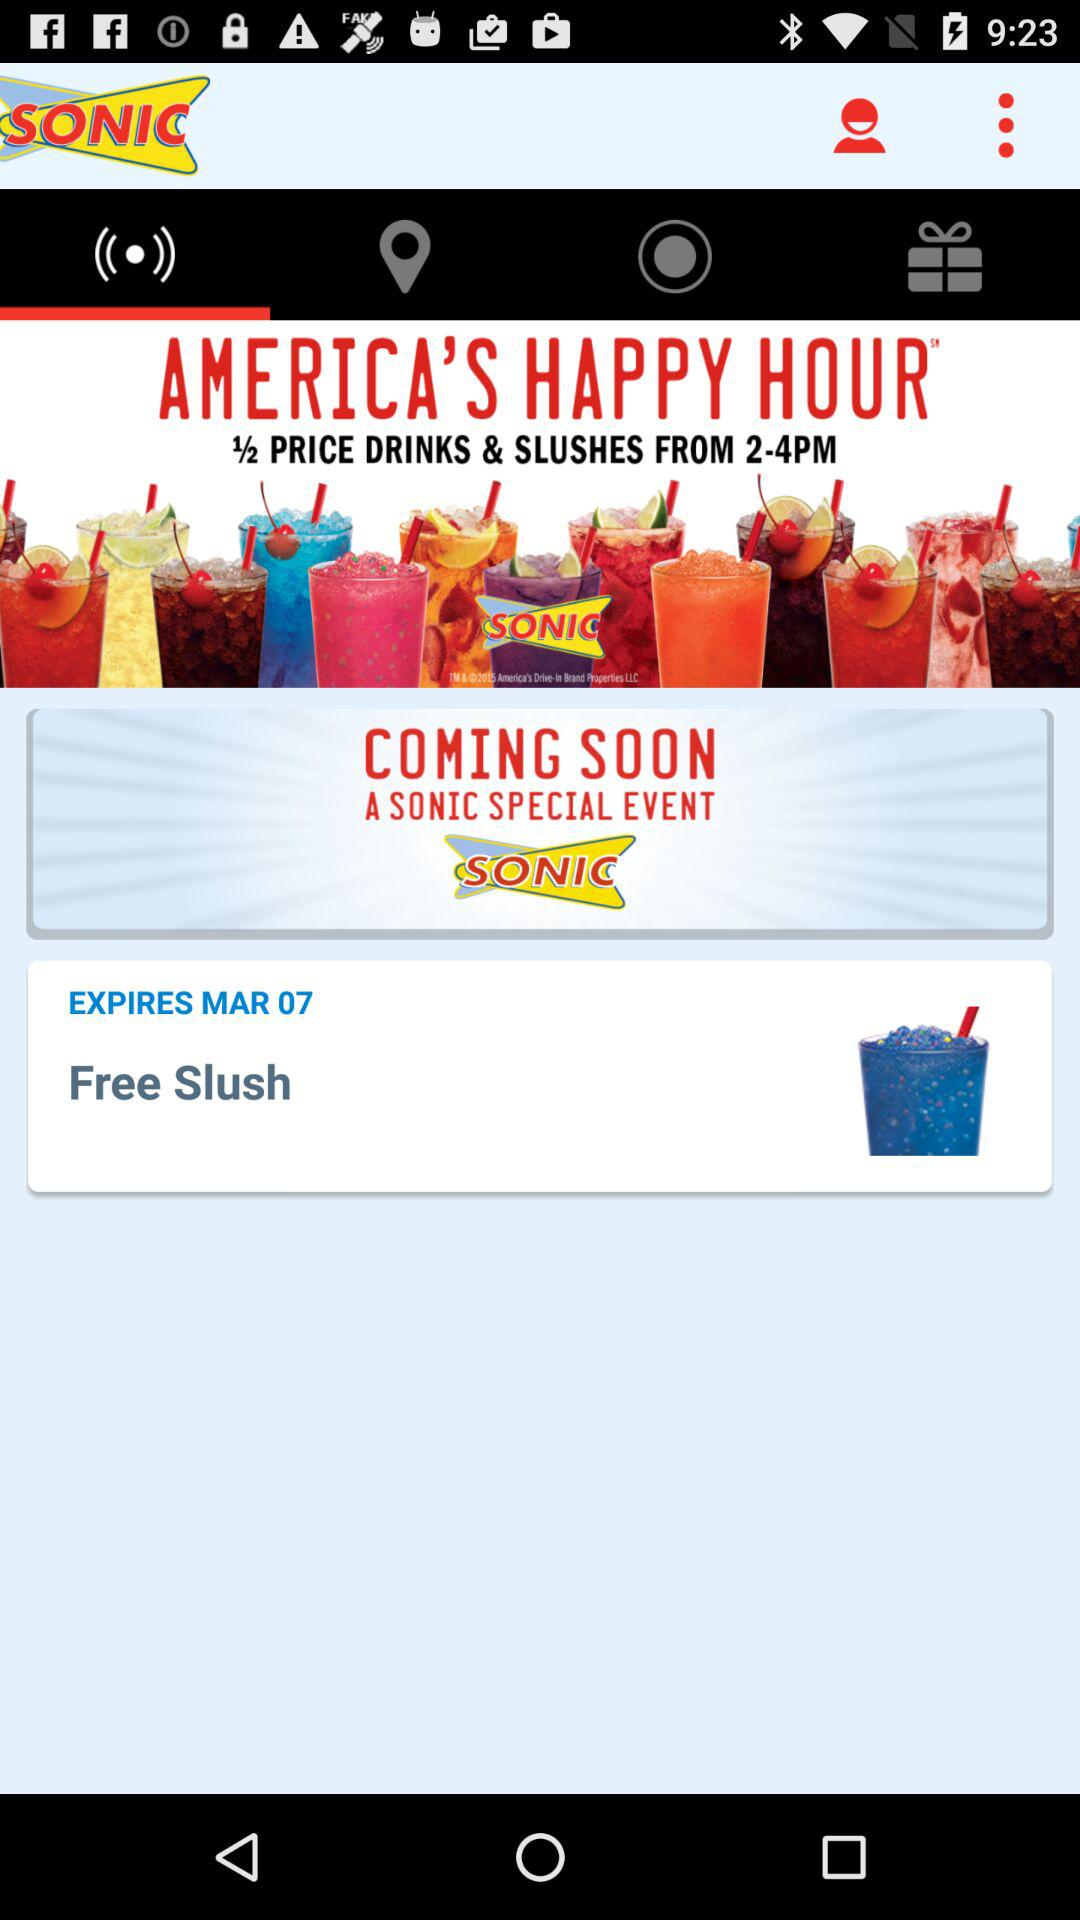What is the time of America's happy hour? The time of America's happy hour is 2PM to 4PM. 